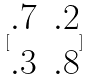Convert formula to latex. <formula><loc_0><loc_0><loc_500><loc_500>[ \begin{matrix} . 7 & . 2 \\ . 3 & . 8 \end{matrix} ]</formula> 